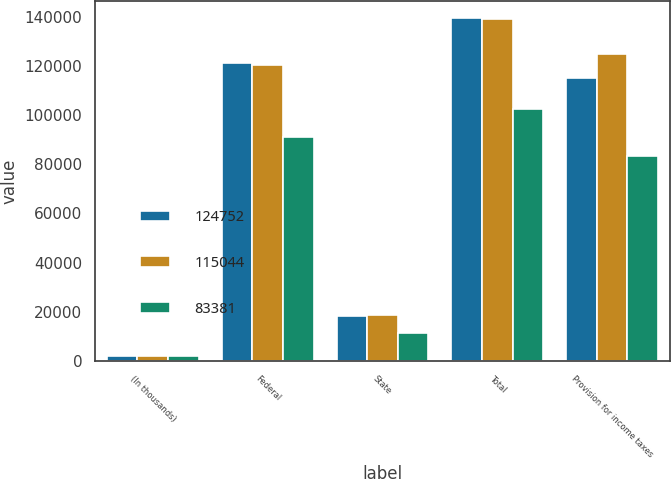<chart> <loc_0><loc_0><loc_500><loc_500><stacked_bar_chart><ecel><fcel>(In thousands)<fcel>Federal<fcel>State<fcel>Total<fcel>Provision for income taxes<nl><fcel>124752<fcel>2008<fcel>121274<fcel>18175<fcel>139449<fcel>115044<nl><fcel>115044<fcel>2007<fcel>120250<fcel>18671<fcel>138921<fcel>124752<nl><fcel>83381<fcel>2006<fcel>91197<fcel>11272<fcel>102469<fcel>83381<nl></chart> 